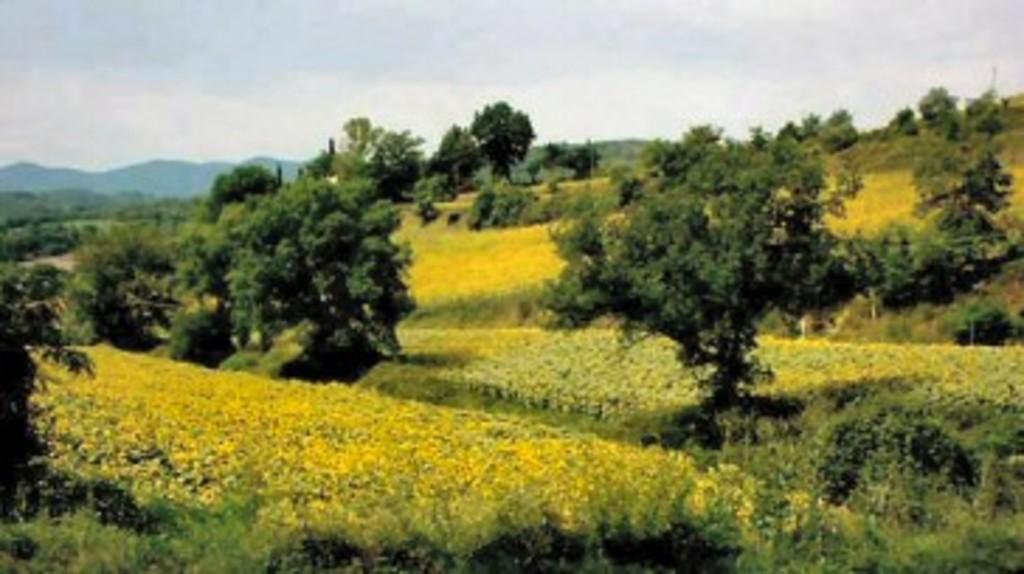Could you give a brief overview of what you see in this image? In this image there are fields, trees, in the background there are mountains and a sky. 